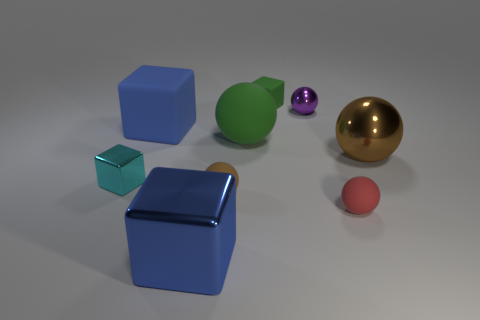Subtract all small green rubber cubes. How many cubes are left? 3 Add 1 big blue matte things. How many objects exist? 10 Subtract all cyan blocks. How many blocks are left? 3 Subtract all blocks. How many objects are left? 5 Subtract 3 balls. How many balls are left? 2 Subtract all purple spheres. How many gray blocks are left? 0 Add 7 large cyan metallic cylinders. How many large cyan metallic cylinders exist? 7 Subtract 0 brown blocks. How many objects are left? 9 Subtract all brown cubes. Subtract all yellow cylinders. How many cubes are left? 4 Subtract all green blocks. Subtract all brown matte balls. How many objects are left? 7 